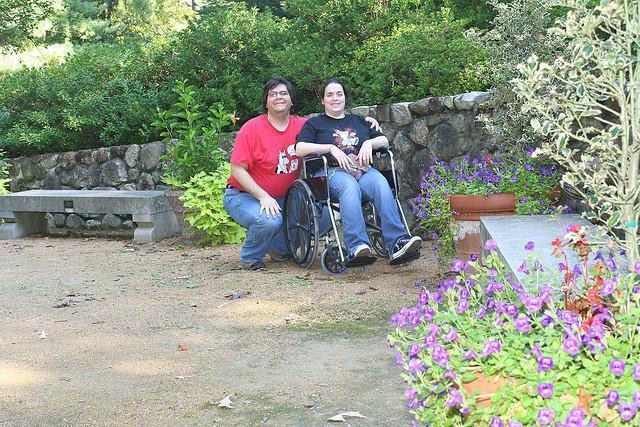How many of these people are women?
Give a very brief answer. 1. How many planters are there?
Give a very brief answer. 2. How many potted plants can you see?
Give a very brief answer. 3. How many people are there?
Give a very brief answer. 2. How many benches are in the picture?
Give a very brief answer. 2. 